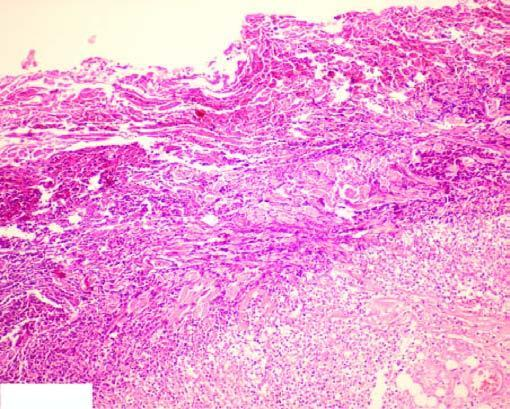what are seen at the periphery?
Answer the question using a single word or phrase. Some macrophages 